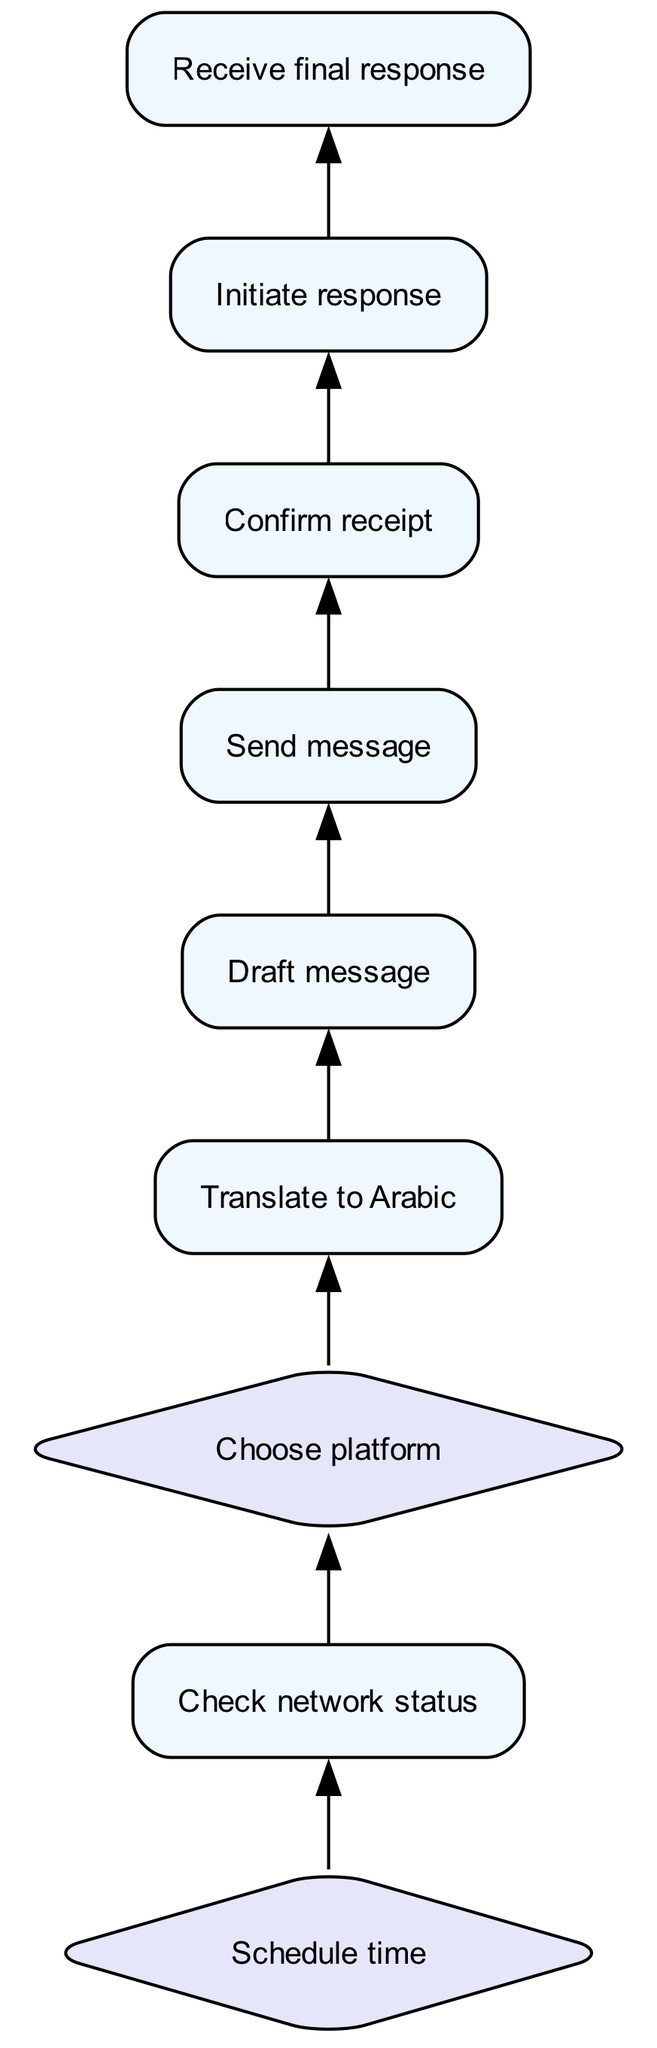What is the first step in the routine? The routine begins with "Schedule time" which is indicated at the bottom of the flowchart. This step is essential to ensure both parties can communicate at a mutually convenient time.
Answer: Schedule time How many processes are in the diagram? By counting the nodes labeled as "Process," there are six processes in the diagram: Receive final response, Confirm receipt, Initiate response, Draft message, Translate to Arabic, and Send message.
Answer: Six What happens after "Send message"? After "Send message," the next action taken is "Confirm receipt," indicating that the sender seeks to verify that the message was successfully received by relatives.
Answer: Confirm receipt What decision must be made regarding communication platforms? The decision to be made is "Choose platform," which involves selecting the preferred communication method such as WhatsApp or Viber.
Answer: Choose platform Which step directly leads to the final output? The final output of the communication routine is achieved through "Receive final response," which is the last process in the diagram indicating that a response has been obtained from the relatives.
Answer: Receive final response What step comes before "Draft message"? Before "Draft message," the process that occurs is "Translate to Arabic." This step is crucial if the drafted message needs to be translated to ensure clarity in communication.
Answer: Translate to Arabic What is necessary to check before choosing a platform? It is necessary to "Check network status" to ensure both parties have stable internet connectivity, as this is essential for effective communication.
Answer: Check network status What type of node follows "Confirm receipt"? The node that follows "Confirm receipt" is "Initiate response," which indicates that once the receipt is confirmed, the response process can begin.
Answer: Initiate response How does the flow begin in the routine? The flow begins with the decision-making process of "Schedule time," which sets the groundwork for subsequent communication actions between the individuals involved.
Answer: Schedule time 